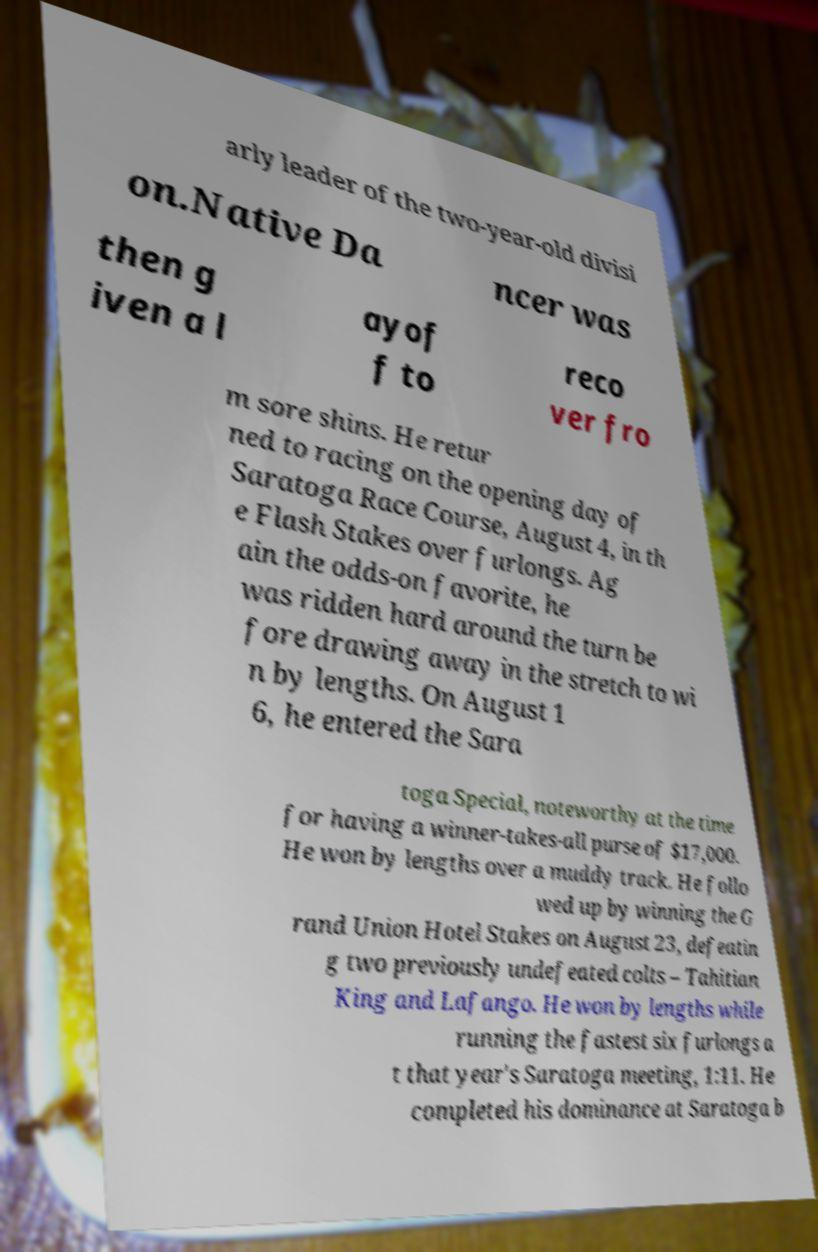Can you accurately transcribe the text from the provided image for me? arly leader of the two-year-old divisi on.Native Da ncer was then g iven a l ayof f to reco ver fro m sore shins. He retur ned to racing on the opening day of Saratoga Race Course, August 4, in th e Flash Stakes over furlongs. Ag ain the odds-on favorite, he was ridden hard around the turn be fore drawing away in the stretch to wi n by lengths. On August 1 6, he entered the Sara toga Special, noteworthy at the time for having a winner-takes-all purse of $17,000. He won by lengths over a muddy track. He follo wed up by winning the G rand Union Hotel Stakes on August 23, defeatin g two previously undefeated colts – Tahitian King and Lafango. He won by lengths while running the fastest six furlongs a t that year's Saratoga meeting, 1:11. He completed his dominance at Saratoga b 